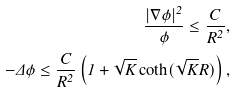<formula> <loc_0><loc_0><loc_500><loc_500>\frac { | \nabla \phi | ^ { 2 } } { \phi } \leq \frac { C } { R ^ { 2 } } , \\ - \Delta \phi \leq \frac { C } { R ^ { 2 } } \left ( 1 + \sqrt { K } \coth ( \sqrt { K } R ) \right ) ,</formula> 